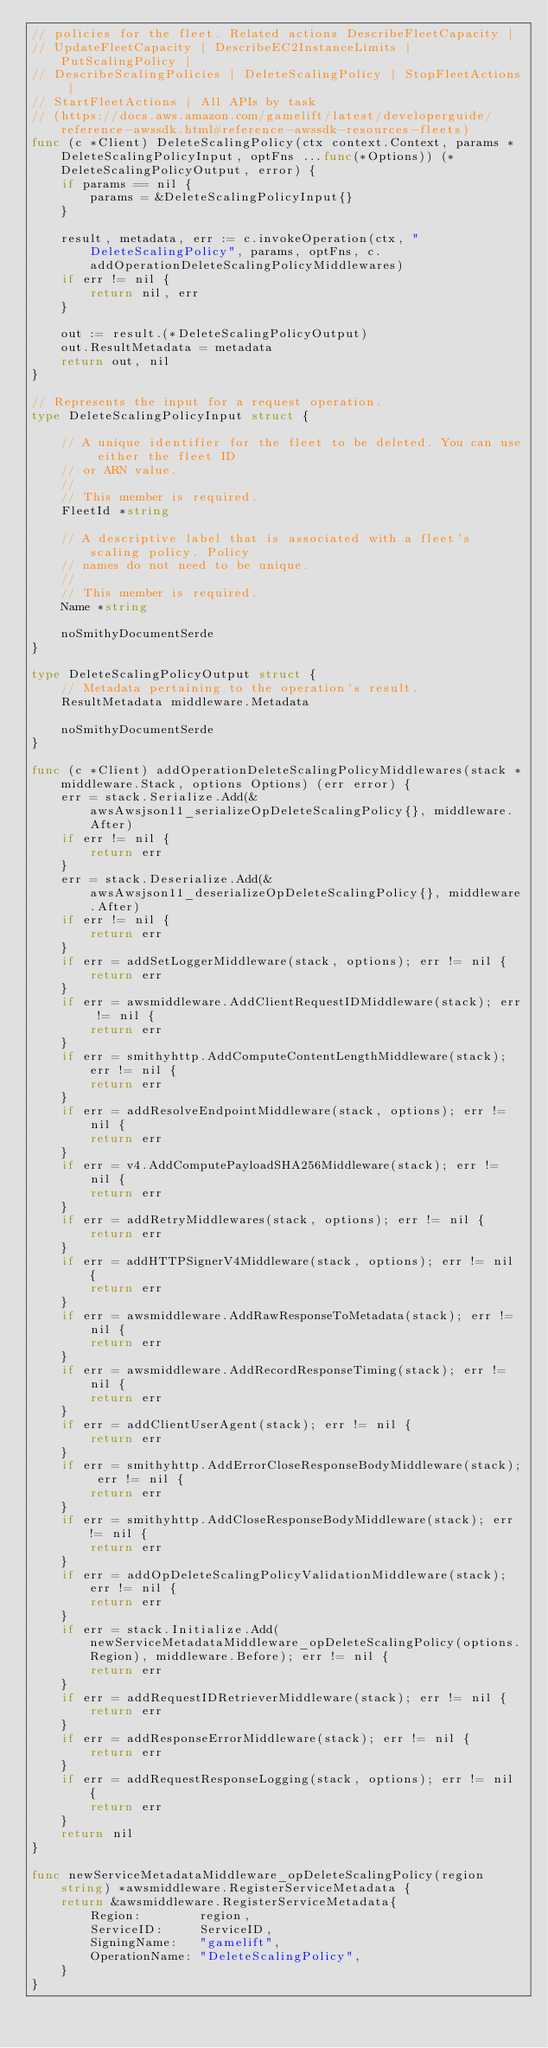<code> <loc_0><loc_0><loc_500><loc_500><_Go_>// policies for the fleet. Related actions DescribeFleetCapacity |
// UpdateFleetCapacity | DescribeEC2InstanceLimits | PutScalingPolicy |
// DescribeScalingPolicies | DeleteScalingPolicy | StopFleetActions |
// StartFleetActions | All APIs by task
// (https://docs.aws.amazon.com/gamelift/latest/developerguide/reference-awssdk.html#reference-awssdk-resources-fleets)
func (c *Client) DeleteScalingPolicy(ctx context.Context, params *DeleteScalingPolicyInput, optFns ...func(*Options)) (*DeleteScalingPolicyOutput, error) {
	if params == nil {
		params = &DeleteScalingPolicyInput{}
	}

	result, metadata, err := c.invokeOperation(ctx, "DeleteScalingPolicy", params, optFns, c.addOperationDeleteScalingPolicyMiddlewares)
	if err != nil {
		return nil, err
	}

	out := result.(*DeleteScalingPolicyOutput)
	out.ResultMetadata = metadata
	return out, nil
}

// Represents the input for a request operation.
type DeleteScalingPolicyInput struct {

	// A unique identifier for the fleet to be deleted. You can use either the fleet ID
	// or ARN value.
	//
	// This member is required.
	FleetId *string

	// A descriptive label that is associated with a fleet's scaling policy. Policy
	// names do not need to be unique.
	//
	// This member is required.
	Name *string

	noSmithyDocumentSerde
}

type DeleteScalingPolicyOutput struct {
	// Metadata pertaining to the operation's result.
	ResultMetadata middleware.Metadata

	noSmithyDocumentSerde
}

func (c *Client) addOperationDeleteScalingPolicyMiddlewares(stack *middleware.Stack, options Options) (err error) {
	err = stack.Serialize.Add(&awsAwsjson11_serializeOpDeleteScalingPolicy{}, middleware.After)
	if err != nil {
		return err
	}
	err = stack.Deserialize.Add(&awsAwsjson11_deserializeOpDeleteScalingPolicy{}, middleware.After)
	if err != nil {
		return err
	}
	if err = addSetLoggerMiddleware(stack, options); err != nil {
		return err
	}
	if err = awsmiddleware.AddClientRequestIDMiddleware(stack); err != nil {
		return err
	}
	if err = smithyhttp.AddComputeContentLengthMiddleware(stack); err != nil {
		return err
	}
	if err = addResolveEndpointMiddleware(stack, options); err != nil {
		return err
	}
	if err = v4.AddComputePayloadSHA256Middleware(stack); err != nil {
		return err
	}
	if err = addRetryMiddlewares(stack, options); err != nil {
		return err
	}
	if err = addHTTPSignerV4Middleware(stack, options); err != nil {
		return err
	}
	if err = awsmiddleware.AddRawResponseToMetadata(stack); err != nil {
		return err
	}
	if err = awsmiddleware.AddRecordResponseTiming(stack); err != nil {
		return err
	}
	if err = addClientUserAgent(stack); err != nil {
		return err
	}
	if err = smithyhttp.AddErrorCloseResponseBodyMiddleware(stack); err != nil {
		return err
	}
	if err = smithyhttp.AddCloseResponseBodyMiddleware(stack); err != nil {
		return err
	}
	if err = addOpDeleteScalingPolicyValidationMiddleware(stack); err != nil {
		return err
	}
	if err = stack.Initialize.Add(newServiceMetadataMiddleware_opDeleteScalingPolicy(options.Region), middleware.Before); err != nil {
		return err
	}
	if err = addRequestIDRetrieverMiddleware(stack); err != nil {
		return err
	}
	if err = addResponseErrorMiddleware(stack); err != nil {
		return err
	}
	if err = addRequestResponseLogging(stack, options); err != nil {
		return err
	}
	return nil
}

func newServiceMetadataMiddleware_opDeleteScalingPolicy(region string) *awsmiddleware.RegisterServiceMetadata {
	return &awsmiddleware.RegisterServiceMetadata{
		Region:        region,
		ServiceID:     ServiceID,
		SigningName:   "gamelift",
		OperationName: "DeleteScalingPolicy",
	}
}
</code> 